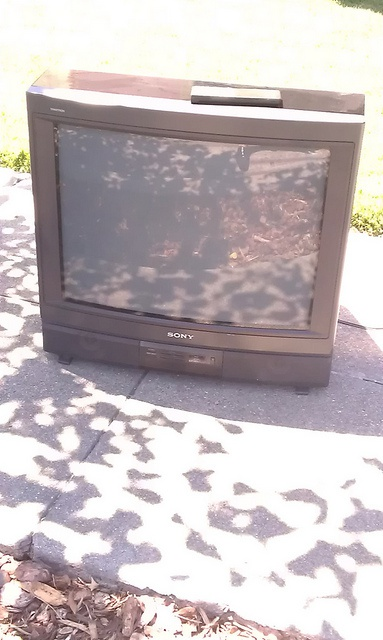Describe the objects in this image and their specific colors. I can see a tv in white and gray tones in this image. 